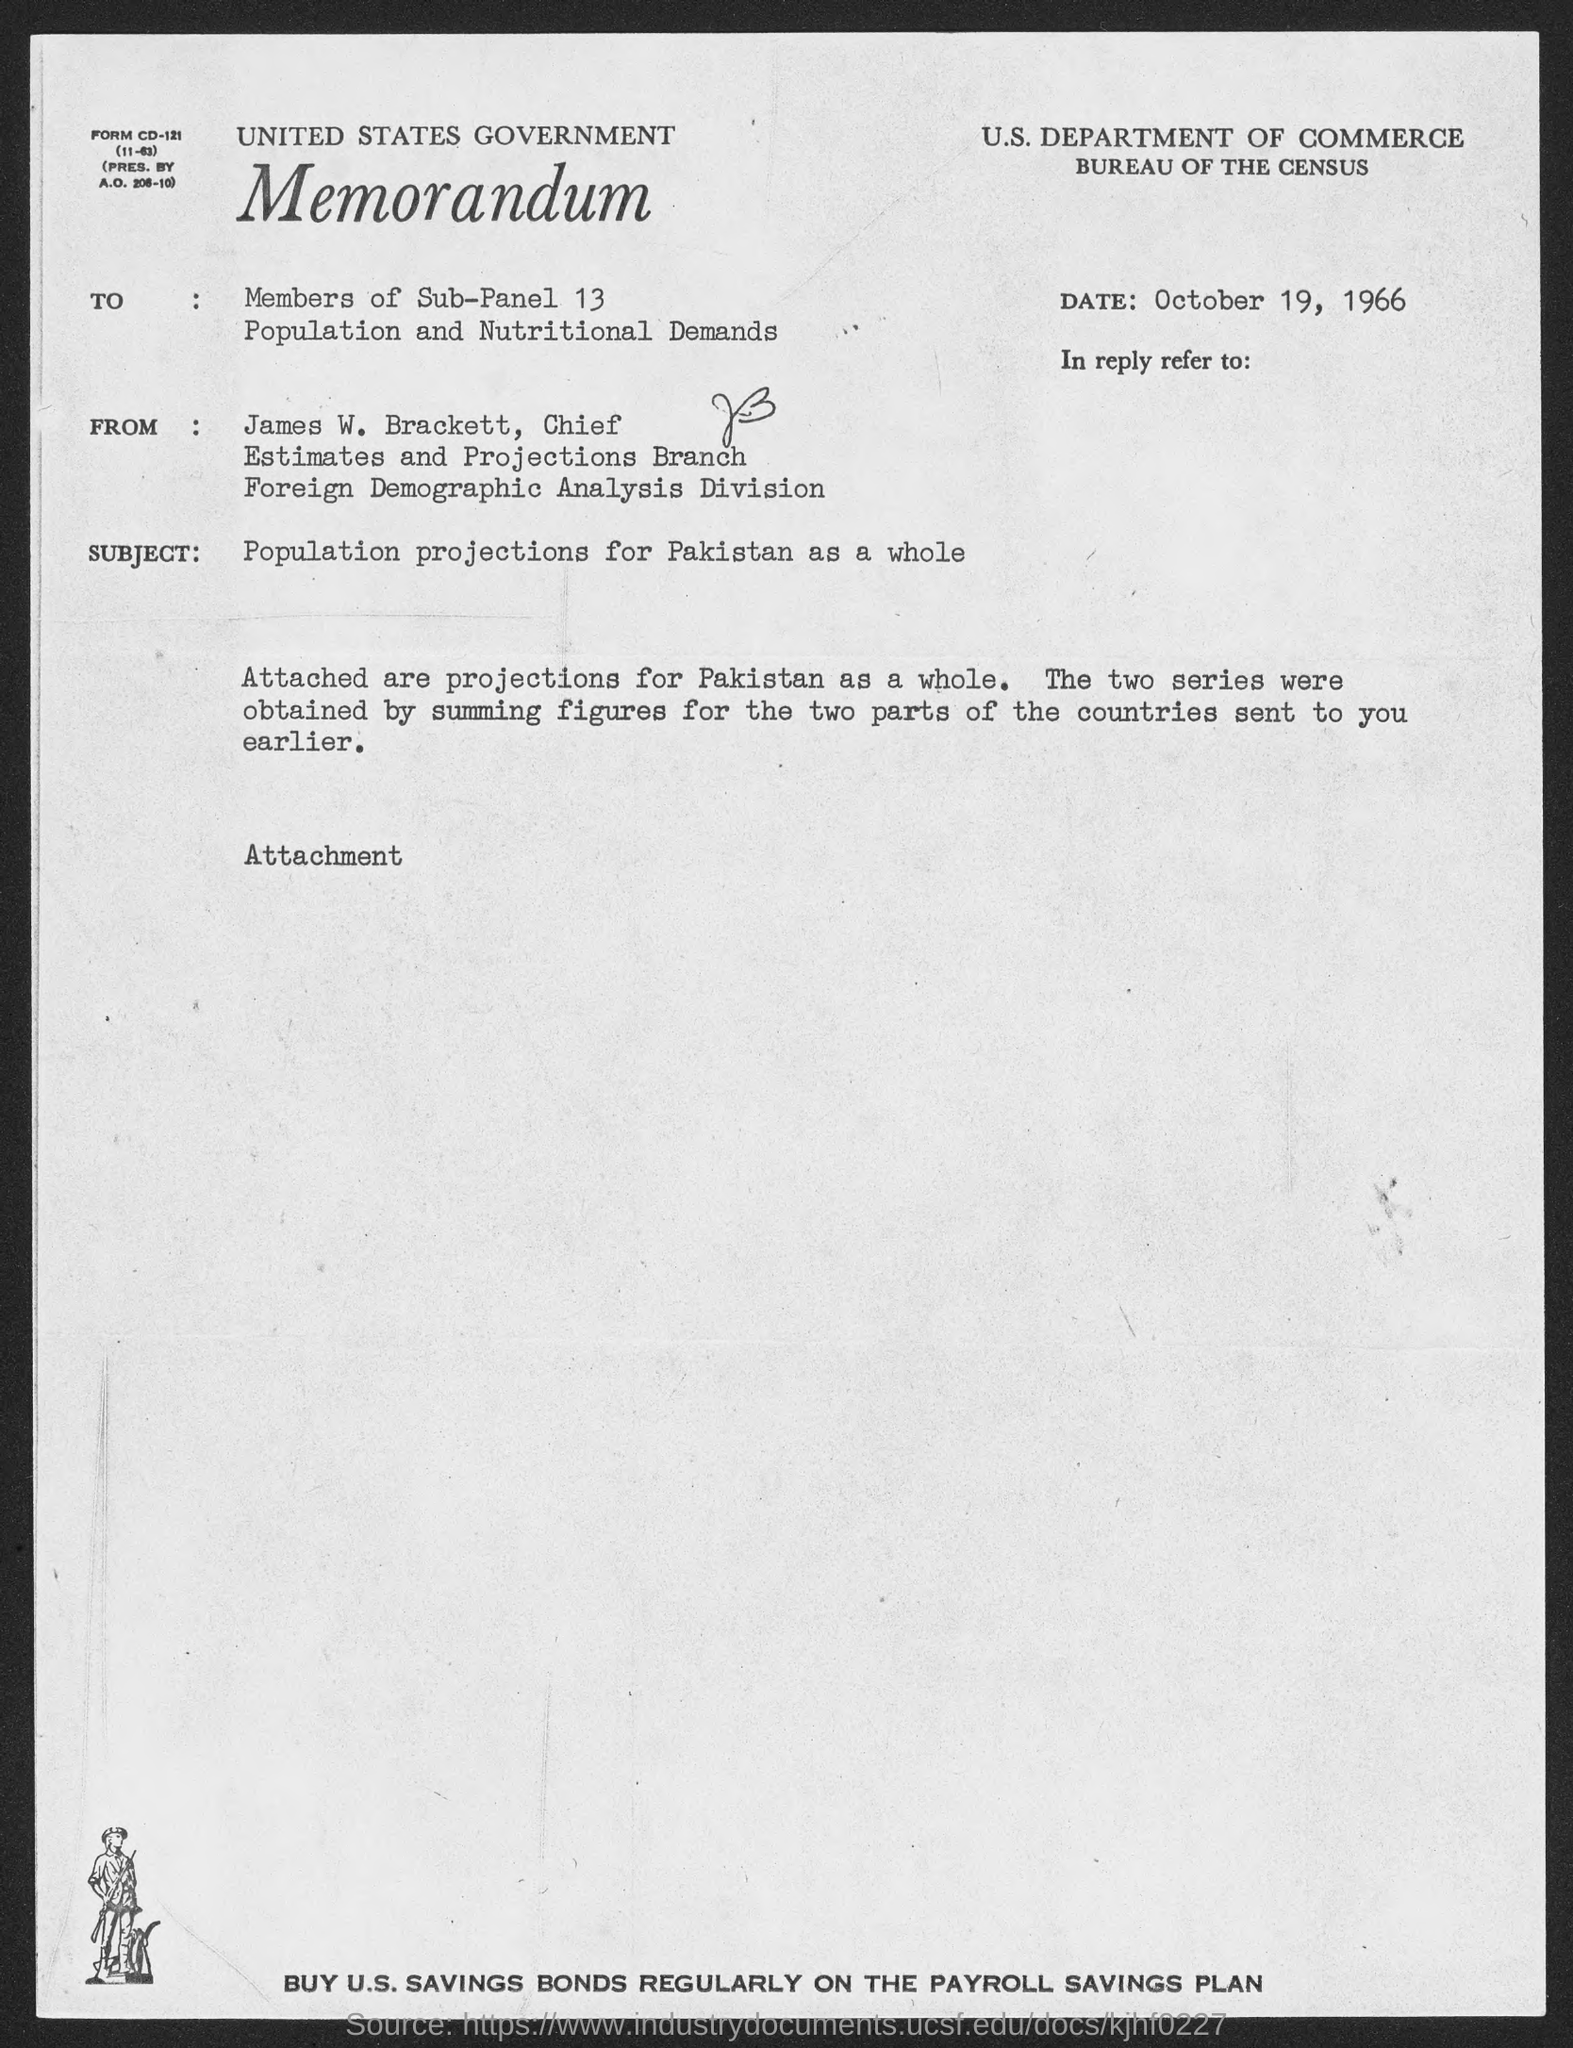When is the memorandum dated?
Ensure brevity in your answer.  October 19, 1966. What is the position of james w. brackett ?
Keep it short and to the point. Chief. What is the subject of memorandum ?
Provide a succinct answer. Population projections for Pakistan as a whole. 